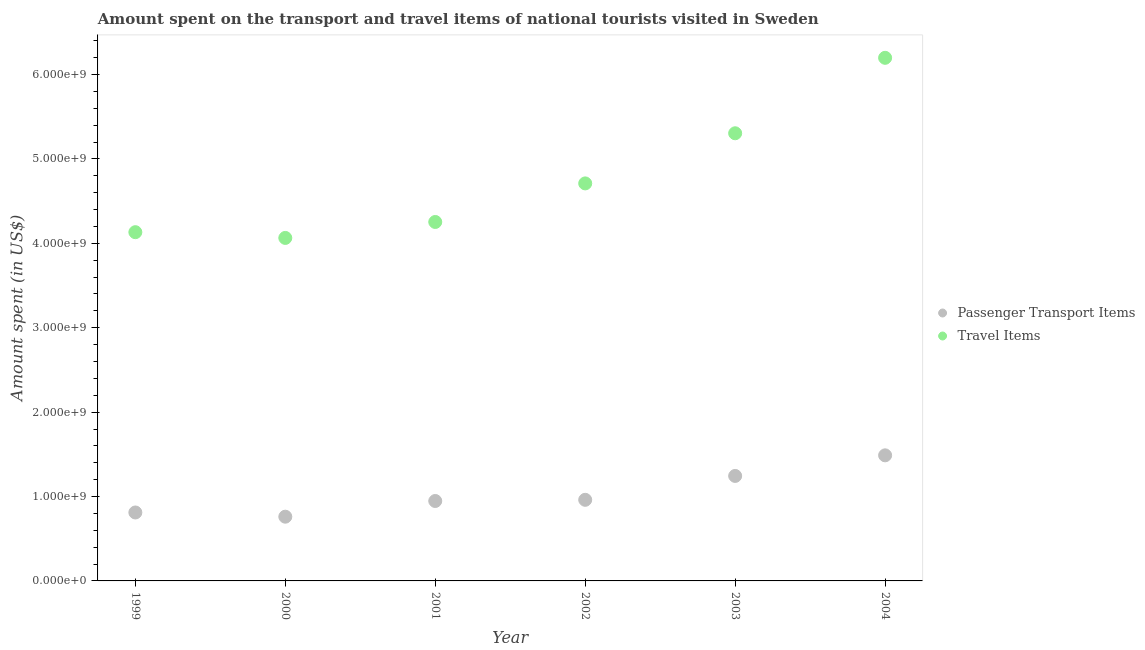What is the amount spent on passenger transport items in 2004?
Offer a terse response. 1.49e+09. Across all years, what is the maximum amount spent in travel items?
Provide a short and direct response. 6.20e+09. Across all years, what is the minimum amount spent in travel items?
Give a very brief answer. 4.06e+09. In which year was the amount spent on passenger transport items minimum?
Your answer should be very brief. 2000. What is the total amount spent in travel items in the graph?
Make the answer very short. 2.87e+1. What is the difference between the amount spent in travel items in 1999 and that in 2004?
Make the answer very short. -2.07e+09. What is the difference between the amount spent in travel items in 1999 and the amount spent on passenger transport items in 2000?
Offer a terse response. 3.37e+09. What is the average amount spent in travel items per year?
Provide a succinct answer. 4.78e+09. In the year 2003, what is the difference between the amount spent on passenger transport items and amount spent in travel items?
Provide a succinct answer. -4.06e+09. In how many years, is the amount spent in travel items greater than 5200000000 US$?
Give a very brief answer. 2. What is the ratio of the amount spent in travel items in 2001 to that in 2004?
Provide a succinct answer. 0.69. What is the difference between the highest and the second highest amount spent on passenger transport items?
Your answer should be compact. 2.44e+08. What is the difference between the highest and the lowest amount spent in travel items?
Provide a succinct answer. 2.13e+09. In how many years, is the amount spent in travel items greater than the average amount spent in travel items taken over all years?
Your answer should be compact. 2. Is the amount spent in travel items strictly greater than the amount spent on passenger transport items over the years?
Your answer should be compact. Yes. How many years are there in the graph?
Provide a succinct answer. 6. Are the values on the major ticks of Y-axis written in scientific E-notation?
Your answer should be very brief. Yes. Does the graph contain any zero values?
Your response must be concise. No. Where does the legend appear in the graph?
Your answer should be very brief. Center right. What is the title of the graph?
Ensure brevity in your answer.  Amount spent on the transport and travel items of national tourists visited in Sweden. What is the label or title of the Y-axis?
Provide a succinct answer. Amount spent (in US$). What is the Amount spent (in US$) of Passenger Transport Items in 1999?
Provide a short and direct response. 8.11e+08. What is the Amount spent (in US$) of Travel Items in 1999?
Your answer should be very brief. 4.13e+09. What is the Amount spent (in US$) in Passenger Transport Items in 2000?
Keep it short and to the point. 7.61e+08. What is the Amount spent (in US$) in Travel Items in 2000?
Your answer should be compact. 4.06e+09. What is the Amount spent (in US$) in Passenger Transport Items in 2001?
Offer a terse response. 9.47e+08. What is the Amount spent (in US$) in Travel Items in 2001?
Your answer should be very brief. 4.25e+09. What is the Amount spent (in US$) of Passenger Transport Items in 2002?
Offer a terse response. 9.61e+08. What is the Amount spent (in US$) of Travel Items in 2002?
Provide a short and direct response. 4.71e+09. What is the Amount spent (in US$) in Passenger Transport Items in 2003?
Your response must be concise. 1.24e+09. What is the Amount spent (in US$) of Travel Items in 2003?
Provide a succinct answer. 5.30e+09. What is the Amount spent (in US$) in Passenger Transport Items in 2004?
Offer a very short reply. 1.49e+09. What is the Amount spent (in US$) in Travel Items in 2004?
Offer a very short reply. 6.20e+09. Across all years, what is the maximum Amount spent (in US$) of Passenger Transport Items?
Offer a very short reply. 1.49e+09. Across all years, what is the maximum Amount spent (in US$) in Travel Items?
Give a very brief answer. 6.20e+09. Across all years, what is the minimum Amount spent (in US$) of Passenger Transport Items?
Give a very brief answer. 7.61e+08. Across all years, what is the minimum Amount spent (in US$) of Travel Items?
Ensure brevity in your answer.  4.06e+09. What is the total Amount spent (in US$) of Passenger Transport Items in the graph?
Keep it short and to the point. 6.21e+09. What is the total Amount spent (in US$) of Travel Items in the graph?
Keep it short and to the point. 2.87e+1. What is the difference between the Amount spent (in US$) in Travel Items in 1999 and that in 2000?
Keep it short and to the point. 6.80e+07. What is the difference between the Amount spent (in US$) in Passenger Transport Items in 1999 and that in 2001?
Make the answer very short. -1.36e+08. What is the difference between the Amount spent (in US$) of Travel Items in 1999 and that in 2001?
Keep it short and to the point. -1.21e+08. What is the difference between the Amount spent (in US$) in Passenger Transport Items in 1999 and that in 2002?
Offer a very short reply. -1.50e+08. What is the difference between the Amount spent (in US$) in Travel Items in 1999 and that in 2002?
Ensure brevity in your answer.  -5.78e+08. What is the difference between the Amount spent (in US$) of Passenger Transport Items in 1999 and that in 2003?
Offer a terse response. -4.33e+08. What is the difference between the Amount spent (in US$) in Travel Items in 1999 and that in 2003?
Keep it short and to the point. -1.17e+09. What is the difference between the Amount spent (in US$) in Passenger Transport Items in 1999 and that in 2004?
Keep it short and to the point. -6.77e+08. What is the difference between the Amount spent (in US$) of Travel Items in 1999 and that in 2004?
Make the answer very short. -2.07e+09. What is the difference between the Amount spent (in US$) in Passenger Transport Items in 2000 and that in 2001?
Offer a terse response. -1.86e+08. What is the difference between the Amount spent (in US$) in Travel Items in 2000 and that in 2001?
Offer a terse response. -1.89e+08. What is the difference between the Amount spent (in US$) in Passenger Transport Items in 2000 and that in 2002?
Your answer should be compact. -2.00e+08. What is the difference between the Amount spent (in US$) in Travel Items in 2000 and that in 2002?
Make the answer very short. -6.46e+08. What is the difference between the Amount spent (in US$) of Passenger Transport Items in 2000 and that in 2003?
Offer a very short reply. -4.83e+08. What is the difference between the Amount spent (in US$) in Travel Items in 2000 and that in 2003?
Provide a succinct answer. -1.24e+09. What is the difference between the Amount spent (in US$) of Passenger Transport Items in 2000 and that in 2004?
Provide a succinct answer. -7.27e+08. What is the difference between the Amount spent (in US$) of Travel Items in 2000 and that in 2004?
Make the answer very short. -2.13e+09. What is the difference between the Amount spent (in US$) in Passenger Transport Items in 2001 and that in 2002?
Your answer should be very brief. -1.40e+07. What is the difference between the Amount spent (in US$) of Travel Items in 2001 and that in 2002?
Ensure brevity in your answer.  -4.57e+08. What is the difference between the Amount spent (in US$) in Passenger Transport Items in 2001 and that in 2003?
Keep it short and to the point. -2.97e+08. What is the difference between the Amount spent (in US$) of Travel Items in 2001 and that in 2003?
Make the answer very short. -1.05e+09. What is the difference between the Amount spent (in US$) of Passenger Transport Items in 2001 and that in 2004?
Provide a short and direct response. -5.41e+08. What is the difference between the Amount spent (in US$) in Travel Items in 2001 and that in 2004?
Your response must be concise. -1.94e+09. What is the difference between the Amount spent (in US$) in Passenger Transport Items in 2002 and that in 2003?
Provide a succinct answer. -2.83e+08. What is the difference between the Amount spent (in US$) in Travel Items in 2002 and that in 2003?
Your response must be concise. -5.94e+08. What is the difference between the Amount spent (in US$) of Passenger Transport Items in 2002 and that in 2004?
Your response must be concise. -5.27e+08. What is the difference between the Amount spent (in US$) of Travel Items in 2002 and that in 2004?
Provide a short and direct response. -1.49e+09. What is the difference between the Amount spent (in US$) of Passenger Transport Items in 2003 and that in 2004?
Make the answer very short. -2.44e+08. What is the difference between the Amount spent (in US$) of Travel Items in 2003 and that in 2004?
Ensure brevity in your answer.  -8.94e+08. What is the difference between the Amount spent (in US$) of Passenger Transport Items in 1999 and the Amount spent (in US$) of Travel Items in 2000?
Give a very brief answer. -3.25e+09. What is the difference between the Amount spent (in US$) of Passenger Transport Items in 1999 and the Amount spent (in US$) of Travel Items in 2001?
Offer a terse response. -3.44e+09. What is the difference between the Amount spent (in US$) in Passenger Transport Items in 1999 and the Amount spent (in US$) in Travel Items in 2002?
Your answer should be compact. -3.90e+09. What is the difference between the Amount spent (in US$) in Passenger Transport Items in 1999 and the Amount spent (in US$) in Travel Items in 2003?
Offer a very short reply. -4.49e+09. What is the difference between the Amount spent (in US$) in Passenger Transport Items in 1999 and the Amount spent (in US$) in Travel Items in 2004?
Provide a succinct answer. -5.39e+09. What is the difference between the Amount spent (in US$) of Passenger Transport Items in 2000 and the Amount spent (in US$) of Travel Items in 2001?
Your response must be concise. -3.49e+09. What is the difference between the Amount spent (in US$) in Passenger Transport Items in 2000 and the Amount spent (in US$) in Travel Items in 2002?
Provide a succinct answer. -3.95e+09. What is the difference between the Amount spent (in US$) of Passenger Transport Items in 2000 and the Amount spent (in US$) of Travel Items in 2003?
Your response must be concise. -4.54e+09. What is the difference between the Amount spent (in US$) of Passenger Transport Items in 2000 and the Amount spent (in US$) of Travel Items in 2004?
Your answer should be very brief. -5.44e+09. What is the difference between the Amount spent (in US$) of Passenger Transport Items in 2001 and the Amount spent (in US$) of Travel Items in 2002?
Provide a succinct answer. -3.76e+09. What is the difference between the Amount spent (in US$) in Passenger Transport Items in 2001 and the Amount spent (in US$) in Travel Items in 2003?
Provide a succinct answer. -4.36e+09. What is the difference between the Amount spent (in US$) in Passenger Transport Items in 2001 and the Amount spent (in US$) in Travel Items in 2004?
Provide a short and direct response. -5.25e+09. What is the difference between the Amount spent (in US$) of Passenger Transport Items in 2002 and the Amount spent (in US$) of Travel Items in 2003?
Your answer should be compact. -4.34e+09. What is the difference between the Amount spent (in US$) of Passenger Transport Items in 2002 and the Amount spent (in US$) of Travel Items in 2004?
Offer a terse response. -5.24e+09. What is the difference between the Amount spent (in US$) in Passenger Transport Items in 2003 and the Amount spent (in US$) in Travel Items in 2004?
Offer a very short reply. -4.95e+09. What is the average Amount spent (in US$) of Passenger Transport Items per year?
Your response must be concise. 1.04e+09. What is the average Amount spent (in US$) of Travel Items per year?
Offer a terse response. 4.78e+09. In the year 1999, what is the difference between the Amount spent (in US$) of Passenger Transport Items and Amount spent (in US$) of Travel Items?
Your response must be concise. -3.32e+09. In the year 2000, what is the difference between the Amount spent (in US$) of Passenger Transport Items and Amount spent (in US$) of Travel Items?
Give a very brief answer. -3.30e+09. In the year 2001, what is the difference between the Amount spent (in US$) in Passenger Transport Items and Amount spent (in US$) in Travel Items?
Offer a very short reply. -3.31e+09. In the year 2002, what is the difference between the Amount spent (in US$) in Passenger Transport Items and Amount spent (in US$) in Travel Items?
Your response must be concise. -3.75e+09. In the year 2003, what is the difference between the Amount spent (in US$) of Passenger Transport Items and Amount spent (in US$) of Travel Items?
Provide a succinct answer. -4.06e+09. In the year 2004, what is the difference between the Amount spent (in US$) in Passenger Transport Items and Amount spent (in US$) in Travel Items?
Ensure brevity in your answer.  -4.71e+09. What is the ratio of the Amount spent (in US$) in Passenger Transport Items in 1999 to that in 2000?
Your answer should be very brief. 1.07. What is the ratio of the Amount spent (in US$) of Travel Items in 1999 to that in 2000?
Offer a very short reply. 1.02. What is the ratio of the Amount spent (in US$) in Passenger Transport Items in 1999 to that in 2001?
Your response must be concise. 0.86. What is the ratio of the Amount spent (in US$) of Travel Items in 1999 to that in 2001?
Provide a succinct answer. 0.97. What is the ratio of the Amount spent (in US$) in Passenger Transport Items in 1999 to that in 2002?
Keep it short and to the point. 0.84. What is the ratio of the Amount spent (in US$) of Travel Items in 1999 to that in 2002?
Provide a short and direct response. 0.88. What is the ratio of the Amount spent (in US$) of Passenger Transport Items in 1999 to that in 2003?
Your response must be concise. 0.65. What is the ratio of the Amount spent (in US$) of Travel Items in 1999 to that in 2003?
Keep it short and to the point. 0.78. What is the ratio of the Amount spent (in US$) in Passenger Transport Items in 1999 to that in 2004?
Provide a short and direct response. 0.55. What is the ratio of the Amount spent (in US$) in Passenger Transport Items in 2000 to that in 2001?
Provide a succinct answer. 0.8. What is the ratio of the Amount spent (in US$) of Travel Items in 2000 to that in 2001?
Offer a terse response. 0.96. What is the ratio of the Amount spent (in US$) in Passenger Transport Items in 2000 to that in 2002?
Offer a terse response. 0.79. What is the ratio of the Amount spent (in US$) of Travel Items in 2000 to that in 2002?
Offer a very short reply. 0.86. What is the ratio of the Amount spent (in US$) in Passenger Transport Items in 2000 to that in 2003?
Provide a short and direct response. 0.61. What is the ratio of the Amount spent (in US$) of Travel Items in 2000 to that in 2003?
Provide a short and direct response. 0.77. What is the ratio of the Amount spent (in US$) in Passenger Transport Items in 2000 to that in 2004?
Offer a very short reply. 0.51. What is the ratio of the Amount spent (in US$) in Travel Items in 2000 to that in 2004?
Make the answer very short. 0.66. What is the ratio of the Amount spent (in US$) in Passenger Transport Items in 2001 to that in 2002?
Your answer should be very brief. 0.99. What is the ratio of the Amount spent (in US$) in Travel Items in 2001 to that in 2002?
Provide a succinct answer. 0.9. What is the ratio of the Amount spent (in US$) in Passenger Transport Items in 2001 to that in 2003?
Provide a succinct answer. 0.76. What is the ratio of the Amount spent (in US$) in Travel Items in 2001 to that in 2003?
Offer a terse response. 0.8. What is the ratio of the Amount spent (in US$) in Passenger Transport Items in 2001 to that in 2004?
Make the answer very short. 0.64. What is the ratio of the Amount spent (in US$) of Travel Items in 2001 to that in 2004?
Your answer should be very brief. 0.69. What is the ratio of the Amount spent (in US$) in Passenger Transport Items in 2002 to that in 2003?
Provide a succinct answer. 0.77. What is the ratio of the Amount spent (in US$) in Travel Items in 2002 to that in 2003?
Your answer should be very brief. 0.89. What is the ratio of the Amount spent (in US$) in Passenger Transport Items in 2002 to that in 2004?
Your response must be concise. 0.65. What is the ratio of the Amount spent (in US$) in Travel Items in 2002 to that in 2004?
Give a very brief answer. 0.76. What is the ratio of the Amount spent (in US$) of Passenger Transport Items in 2003 to that in 2004?
Your answer should be compact. 0.84. What is the ratio of the Amount spent (in US$) of Travel Items in 2003 to that in 2004?
Make the answer very short. 0.86. What is the difference between the highest and the second highest Amount spent (in US$) of Passenger Transport Items?
Make the answer very short. 2.44e+08. What is the difference between the highest and the second highest Amount spent (in US$) of Travel Items?
Your answer should be compact. 8.94e+08. What is the difference between the highest and the lowest Amount spent (in US$) in Passenger Transport Items?
Keep it short and to the point. 7.27e+08. What is the difference between the highest and the lowest Amount spent (in US$) in Travel Items?
Your answer should be very brief. 2.13e+09. 